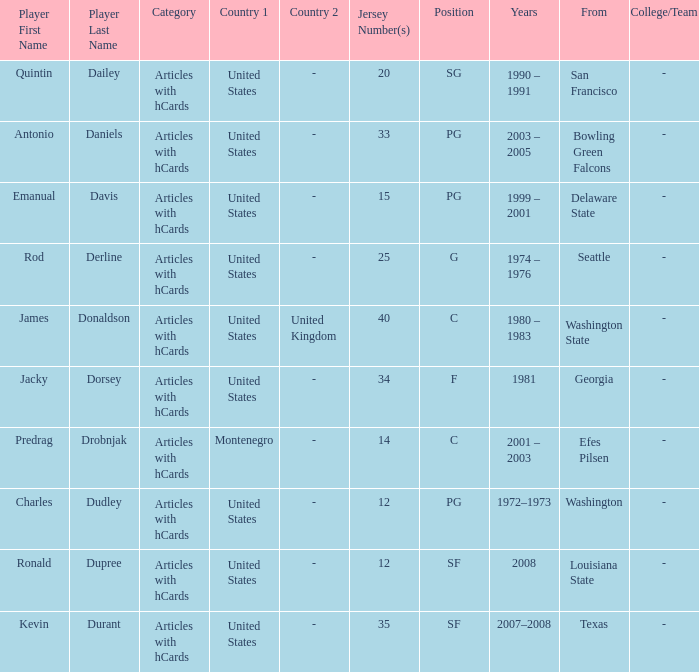What years did the united states player with a jersey number 25 who attended delaware state play? 1999 – 2001. 